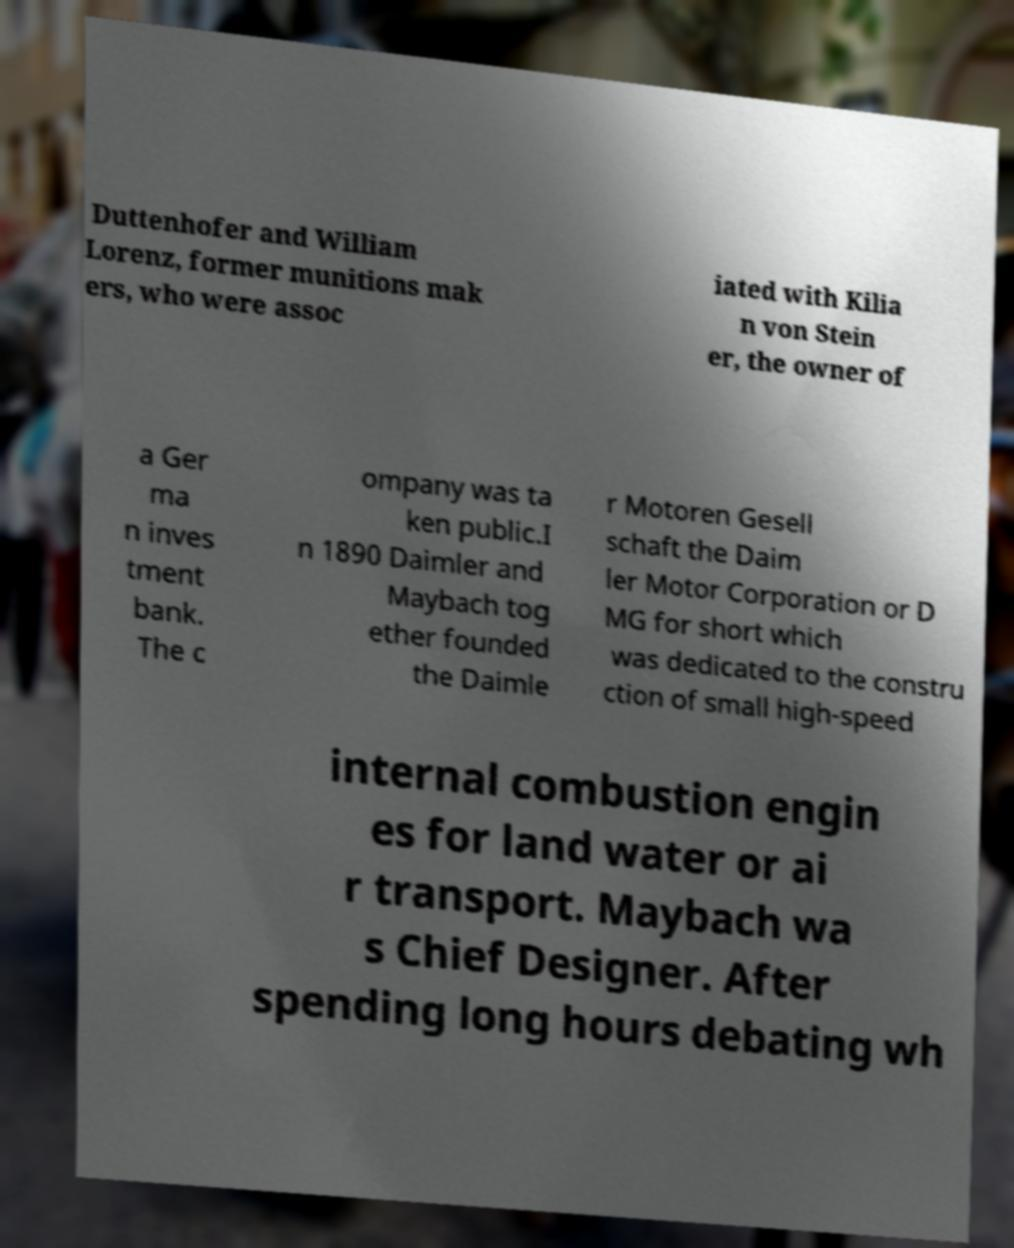There's text embedded in this image that I need extracted. Can you transcribe it verbatim? Duttenhofer and William Lorenz, former munitions mak ers, who were assoc iated with Kilia n von Stein er, the owner of a Ger ma n inves tment bank. The c ompany was ta ken public.I n 1890 Daimler and Maybach tog ether founded the Daimle r Motoren Gesell schaft the Daim ler Motor Corporation or D MG for short which was dedicated to the constru ction of small high-speed internal combustion engin es for land water or ai r transport. Maybach wa s Chief Designer. After spending long hours debating wh 